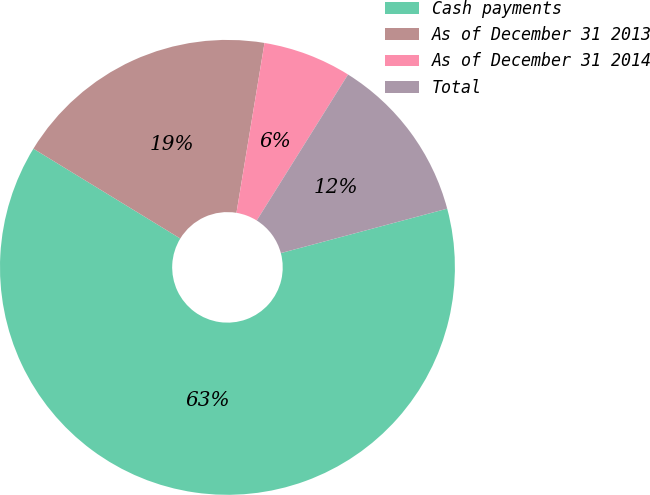<chart> <loc_0><loc_0><loc_500><loc_500><pie_chart><fcel>Cash payments<fcel>As of December 31 2013<fcel>As of December 31 2014<fcel>Total<nl><fcel>62.89%<fcel>18.87%<fcel>6.29%<fcel>11.95%<nl></chart> 